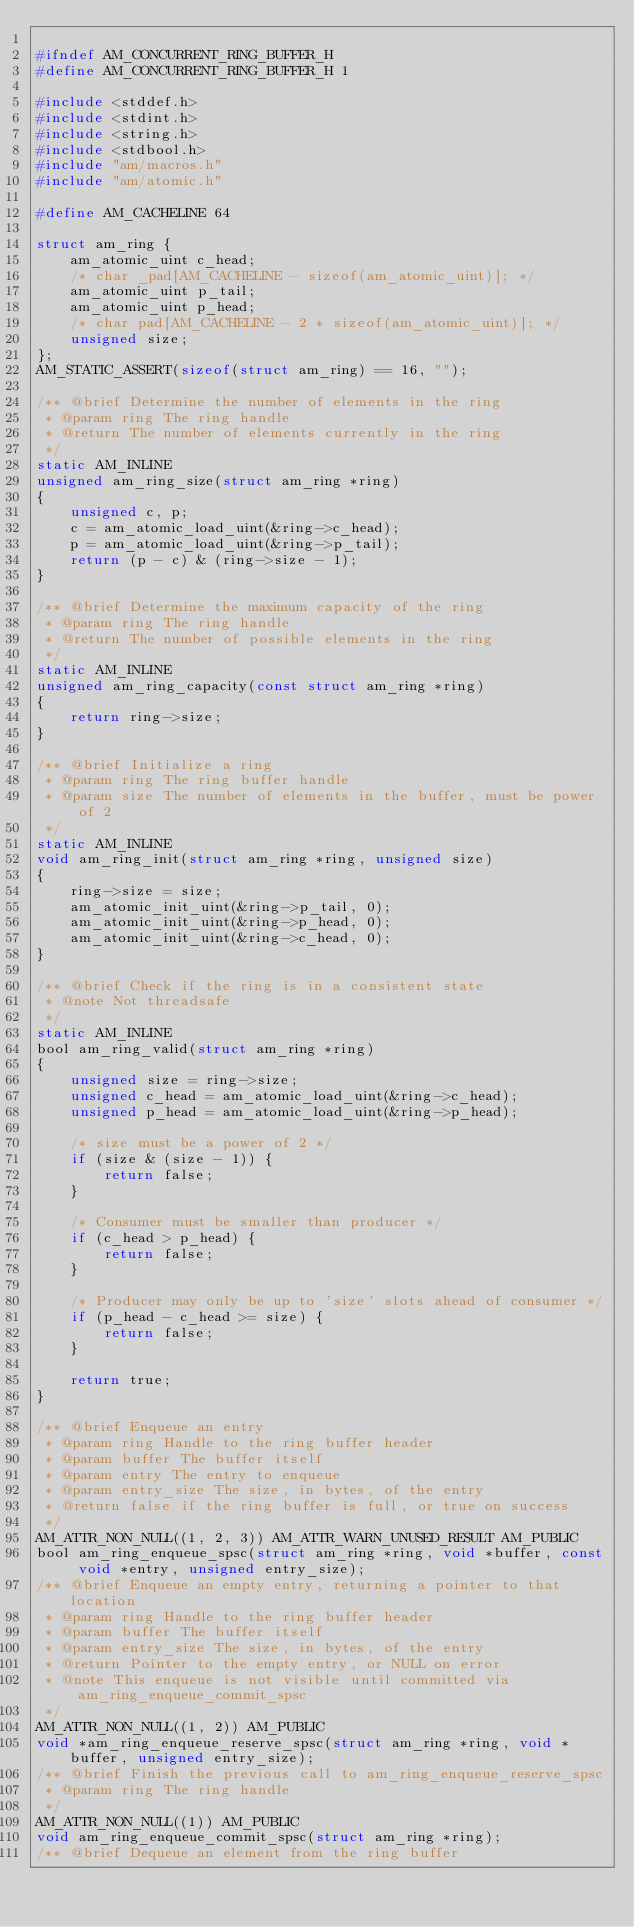<code> <loc_0><loc_0><loc_500><loc_500><_C_>
#ifndef AM_CONCURRENT_RING_BUFFER_H
#define AM_CONCURRENT_RING_BUFFER_H 1

#include <stddef.h>
#include <stdint.h>
#include <string.h>
#include <stdbool.h>
#include "am/macros.h"
#include "am/atomic.h"

#define AM_CACHELINE 64

struct am_ring {
    am_atomic_uint c_head;
    /* char _pad[AM_CACHELINE - sizeof(am_atomic_uint)]; */
    am_atomic_uint p_tail;
    am_atomic_uint p_head;
    /* char pad[AM_CACHELINE - 2 * sizeof(am_atomic_uint)]; */
    unsigned size;
};
AM_STATIC_ASSERT(sizeof(struct am_ring) == 16, "");

/** @brief Determine the number of elements in the ring
 * @param ring The ring handle
 * @return The number of elements currently in the ring
 */
static AM_INLINE
unsigned am_ring_size(struct am_ring *ring)
{
    unsigned c, p;
    c = am_atomic_load_uint(&ring->c_head);
    p = am_atomic_load_uint(&ring->p_tail);
    return (p - c) & (ring->size - 1);
}

/** @brief Determine the maximum capacity of the ring
 * @param ring The ring handle
 * @return The number of possible elements in the ring
 */
static AM_INLINE
unsigned am_ring_capacity(const struct am_ring *ring)
{
    return ring->size;
}

/** @brief Initialize a ring
 * @param ring The ring buffer handle
 * @param size The number of elements in the buffer, must be power of 2
 */
static AM_INLINE
void am_ring_init(struct am_ring *ring, unsigned size)
{
    ring->size = size;
    am_atomic_init_uint(&ring->p_tail, 0);
    am_atomic_init_uint(&ring->p_head, 0);
    am_atomic_init_uint(&ring->c_head, 0);
}

/** @brief Check if the ring is in a consistent state
 * @note Not threadsafe
 */
static AM_INLINE
bool am_ring_valid(struct am_ring *ring)
{
    unsigned size = ring->size;
    unsigned c_head = am_atomic_load_uint(&ring->c_head);
    unsigned p_head = am_atomic_load_uint(&ring->p_head);

    /* size must be a power of 2 */
    if (size & (size - 1)) {
        return false;
    }

    /* Consumer must be smaller than producer */
    if (c_head > p_head) {
        return false;
    }

    /* Producer may only be up to 'size' slots ahead of consumer */
    if (p_head - c_head >= size) {
        return false;
    }

    return true;
}

/** @brief Enqueue an entry
 * @param ring Handle to the ring buffer header
 * @param buffer The buffer itself
 * @param entry The entry to enqueue
 * @param entry_size The size, in bytes, of the entry
 * @return false if the ring buffer is full, or true on success
 */
AM_ATTR_NON_NULL((1, 2, 3)) AM_ATTR_WARN_UNUSED_RESULT AM_PUBLIC
bool am_ring_enqueue_spsc(struct am_ring *ring, void *buffer, const void *entry, unsigned entry_size);
/** @brief Enqueue an empty entry, returning a pointer to that location
 * @param ring Handle to the ring buffer header
 * @param buffer The buffer itself
 * @param entry_size The size, in bytes, of the entry
 * @return Pointer to the empty entry, or NULL on error
 * @note This enqueue is not visible until committed via am_ring_enqueue_commit_spsc
 */
AM_ATTR_NON_NULL((1, 2)) AM_PUBLIC
void *am_ring_enqueue_reserve_spsc(struct am_ring *ring, void *buffer, unsigned entry_size);
/** @brief Finish the previous call to am_ring_enqueue_reserve_spsc
 * @param ring The ring handle
 */
AM_ATTR_NON_NULL((1)) AM_PUBLIC
void am_ring_enqueue_commit_spsc(struct am_ring *ring);
/** @brief Dequeue an element from the ring buffer</code> 